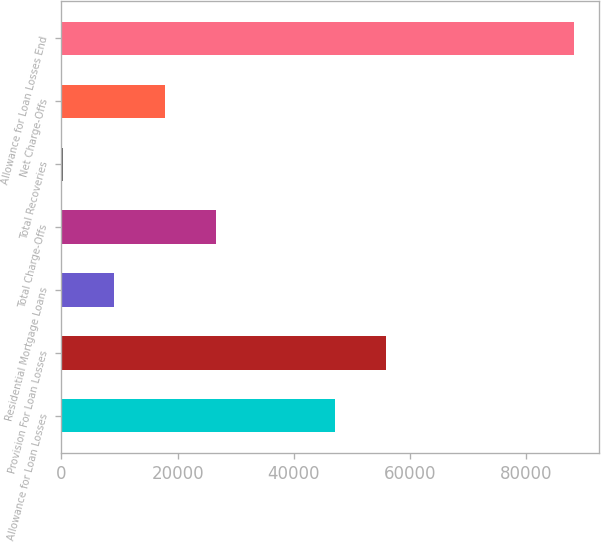<chart> <loc_0><loc_0><loc_500><loc_500><bar_chart><fcel>Allowance for Loan Losses<fcel>Provision For Loan Losses<fcel>Residential Mortgage Loans<fcel>Total Charge-Offs<fcel>Total Recoveries<fcel>Net Charge-Offs<fcel>Allowance for Loan Losses End<nl><fcel>47022<fcel>55807.7<fcel>9083.7<fcel>26655.1<fcel>298<fcel>17869.4<fcel>88155<nl></chart> 